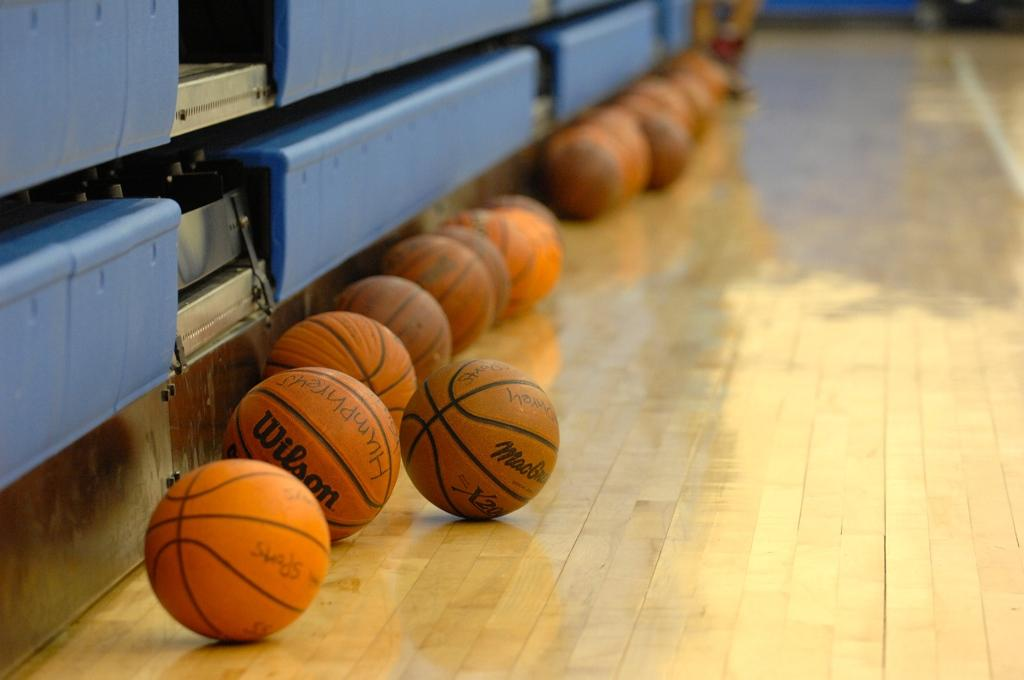What is on the floor in the image? There are balls on the floor in the image. What can be seen on the left side of the image? There are objects on the left side of the image. What type of ink is being used to draw on the stove in the image? There is no stove or ink present in the image; it features balls on the floor and objects on the left side. How much dirt can be seen on the floor in the image? There is no dirt visible on the floor in the image; it features balls on the floor and objects on the left side. 